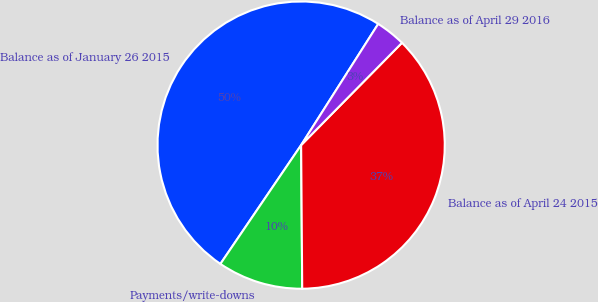Convert chart to OTSL. <chart><loc_0><loc_0><loc_500><loc_500><pie_chart><fcel>Balance as of January 26 2015<fcel>Payments/write-downs<fcel>Balance as of April 24 2015<fcel>Balance as of April 29 2016<nl><fcel>49.52%<fcel>9.62%<fcel>37.5%<fcel>3.37%<nl></chart> 